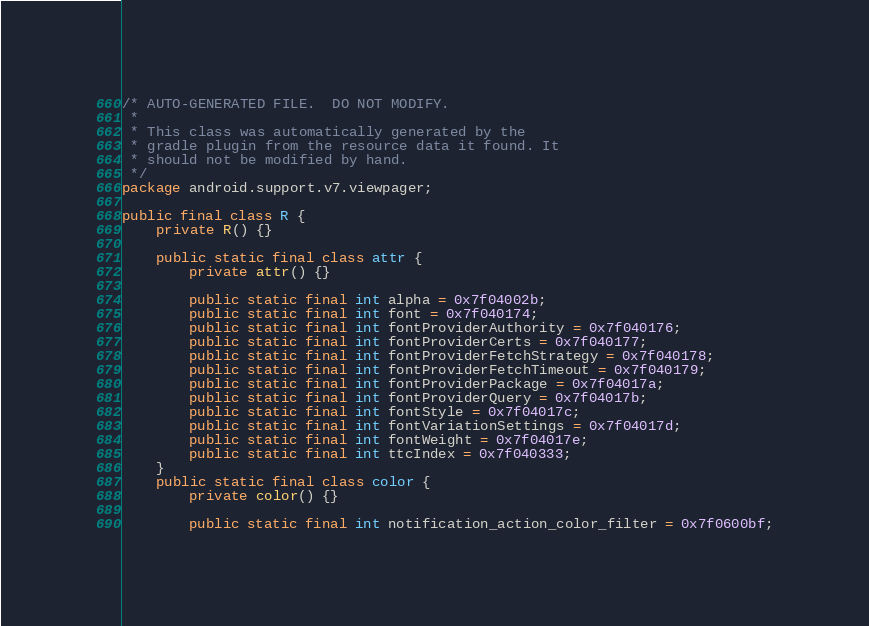Convert code to text. <code><loc_0><loc_0><loc_500><loc_500><_Java_>/* AUTO-GENERATED FILE.  DO NOT MODIFY.
 *
 * This class was automatically generated by the
 * gradle plugin from the resource data it found. It
 * should not be modified by hand.
 */
package android.support.v7.viewpager;

public final class R {
    private R() {}

    public static final class attr {
        private attr() {}

        public static final int alpha = 0x7f04002b;
        public static final int font = 0x7f040174;
        public static final int fontProviderAuthority = 0x7f040176;
        public static final int fontProviderCerts = 0x7f040177;
        public static final int fontProviderFetchStrategy = 0x7f040178;
        public static final int fontProviderFetchTimeout = 0x7f040179;
        public static final int fontProviderPackage = 0x7f04017a;
        public static final int fontProviderQuery = 0x7f04017b;
        public static final int fontStyle = 0x7f04017c;
        public static final int fontVariationSettings = 0x7f04017d;
        public static final int fontWeight = 0x7f04017e;
        public static final int ttcIndex = 0x7f040333;
    }
    public static final class color {
        private color() {}

        public static final int notification_action_color_filter = 0x7f0600bf;</code> 